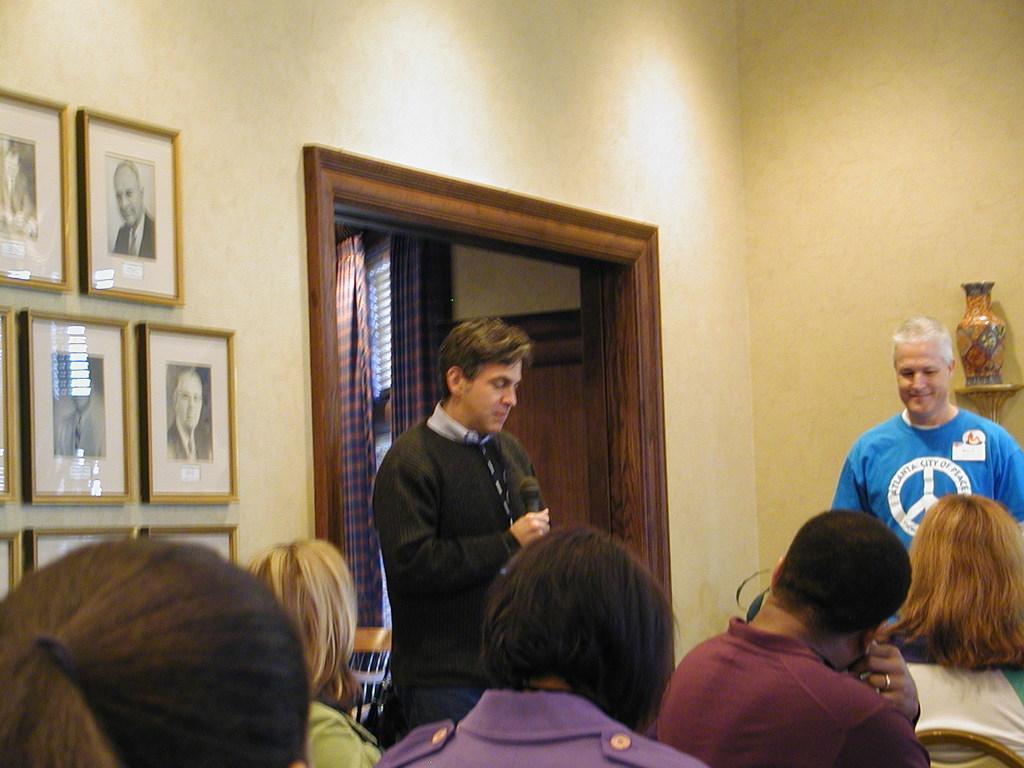Please provide a concise description of this image. In the foreground of the picture we can see group of people and chair. On the left there are frames and wall. In the middle of the picture we can see door, curtain and wall. On the right there is a flower vase. 